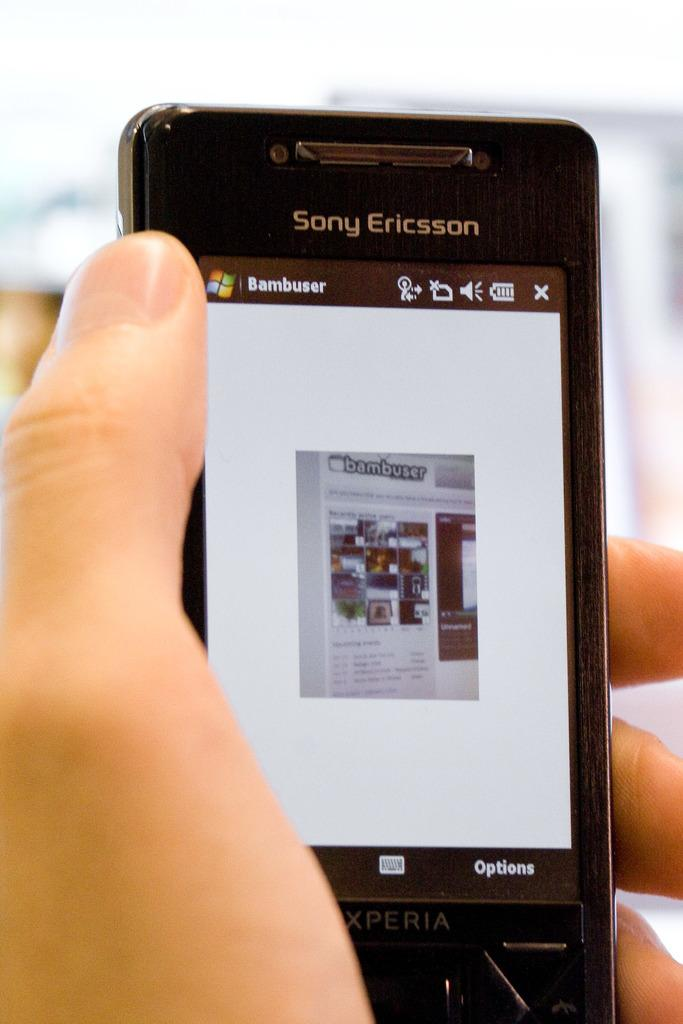<image>
Provide a brief description of the given image. Black Sony Ericsson Xperia with a Bambuser logo. 